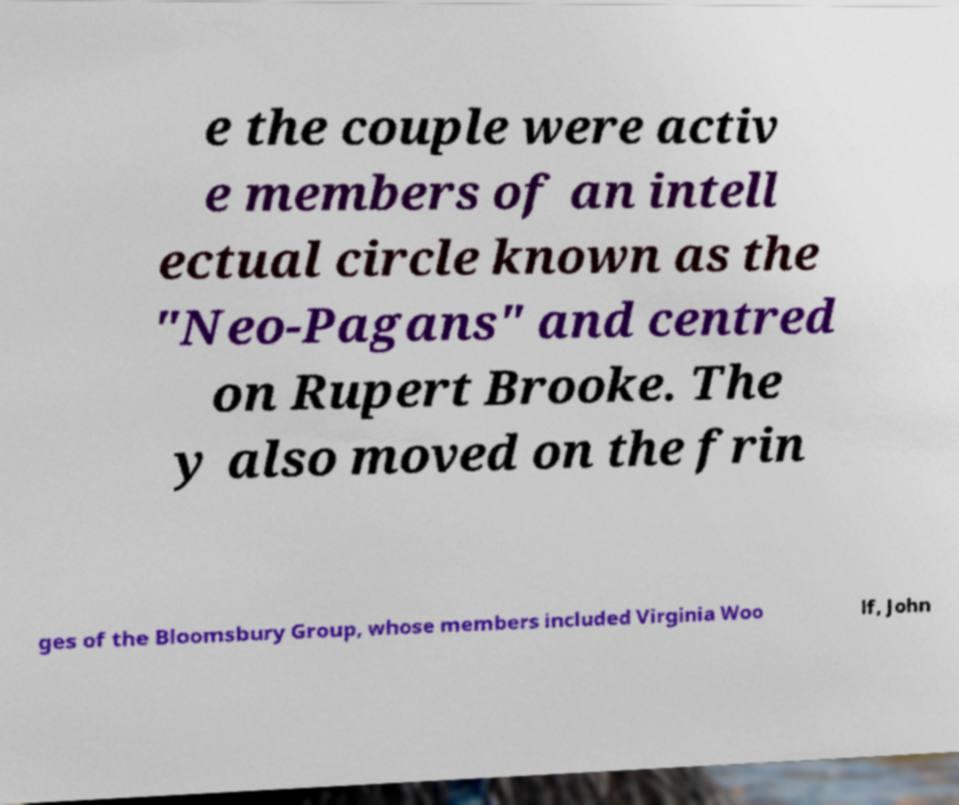Could you assist in decoding the text presented in this image and type it out clearly? e the couple were activ e members of an intell ectual circle known as the "Neo-Pagans" and centred on Rupert Brooke. The y also moved on the frin ges of the Bloomsbury Group, whose members included Virginia Woo lf, John 